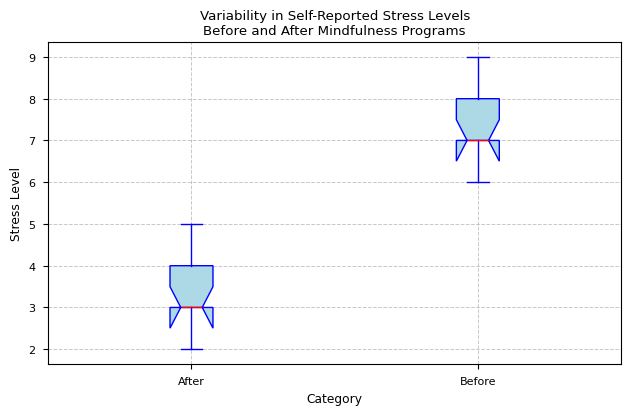What's the median stress level before and after the mindfulness programs? To find the median, locate the middle value when the numbers are ordered. The median for "Before" is 7 (ordered: 6, 6, 7, 7, 7, 7, 8, 8, 8, 9). The median for "After" is 3.5 (ordered: 2, 3, 3, 3, 3, 3, 4, 4, 4, 5).
Answer: Before: 7, After: 3.5 Which category has the higher interquartile range (IQR) of stress levels? The interquartile range (IQR) is the difference between the third quartile (Q3) and the first quartile (Q1). The IQR for "Before" is 2 (Q3-Q1=8-6), while for "After" it is 1 (Q3-Q1=4-3). The "Before" category has the higher IQR.
Answer: Before What is the range of the stress levels reported before the mindfulness programs? The range is the difference between the maximum and minimum values. For "Before", the range is 9 - 6 = 3.
Answer: 3 What are the minimum stress levels before and after the mindfulness programs? The minimum value is the lowest point in the dataset. The minimum stress level "Before" the program is 6, and "After" it is 2.
Answer: Before: 6, After: 2 How does the median stress level change after participating in the mindfulness programs? The median stress level "Before" is 7, and "After" is 3.5. The change is 3.5 - 7 = -3.5, indicating a reduction of 3.5.
Answer: Decreases by 3.5 Are there any outliers in the stress levels reported after the mindfulness programs? An outlier is a data point that is significantly different from others. Based on the boxplot, no outliers are marked for the "After" group.
Answer: No Which category shows more variability in stress levels? Variability in a boxplot can be interpreted from the length of the box and whiskers. The "Before" category shows more variability as it has a wider range and IQR compared to the "After" category.
Answer: Before What is the median stress level difference between the two categories? The median for "Before" is 7 and for "After" is 3.5. The difference is 7 - 3.5 = 3.5.
Answer: 3.5 How does the color of the box plot elements help in interpreting the data? The color helps distinguish between different components, with light blue used for the boxes, blue for the edges, caps, and whiskers, and red for the median. This makes it easier to visually differentiate these elements and understand the central tendency and spread.
Answer: Differentiates components Which category has a lower maximum stress level? By looking at the maximum values denoted by the top whisker, "Before" has a maximum of 9 and "After" has a maximum of 5. Therefore, the "After" category has a lower maximum stress level.
Answer: After 